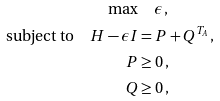<formula> <loc_0><loc_0><loc_500><loc_500>\max & \quad \epsilon \, , \\ \text {subject to} \quad H - \epsilon I & = P + Q ^ { T _ { A } } \, , \\ P & \geq 0 \, , \\ Q & \geq 0 \, ,</formula> 